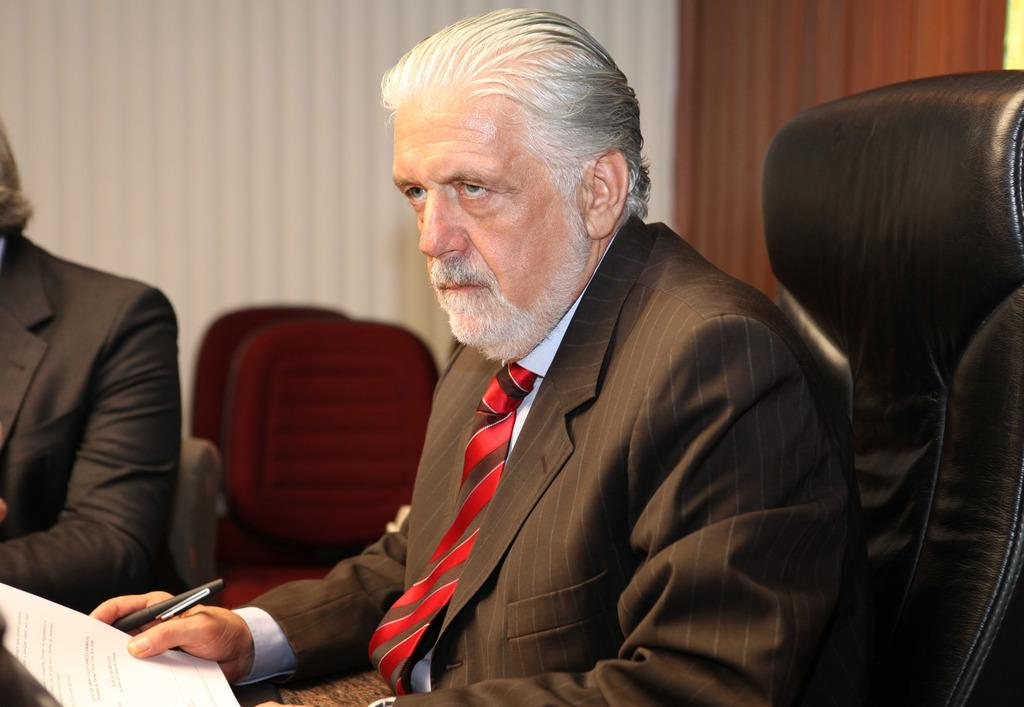How many people are in the image? There are two people in the image. What are the people doing in the image? The two people are sitting on chairs. What objects are the people holding in the image? One or both of the people are holding a paper and a pen. What type of waves can be seen in the image? There are no waves present in the image. What are the people's interests or hobbies in the image? The image does not provide information about the people's interests or hobbies. 